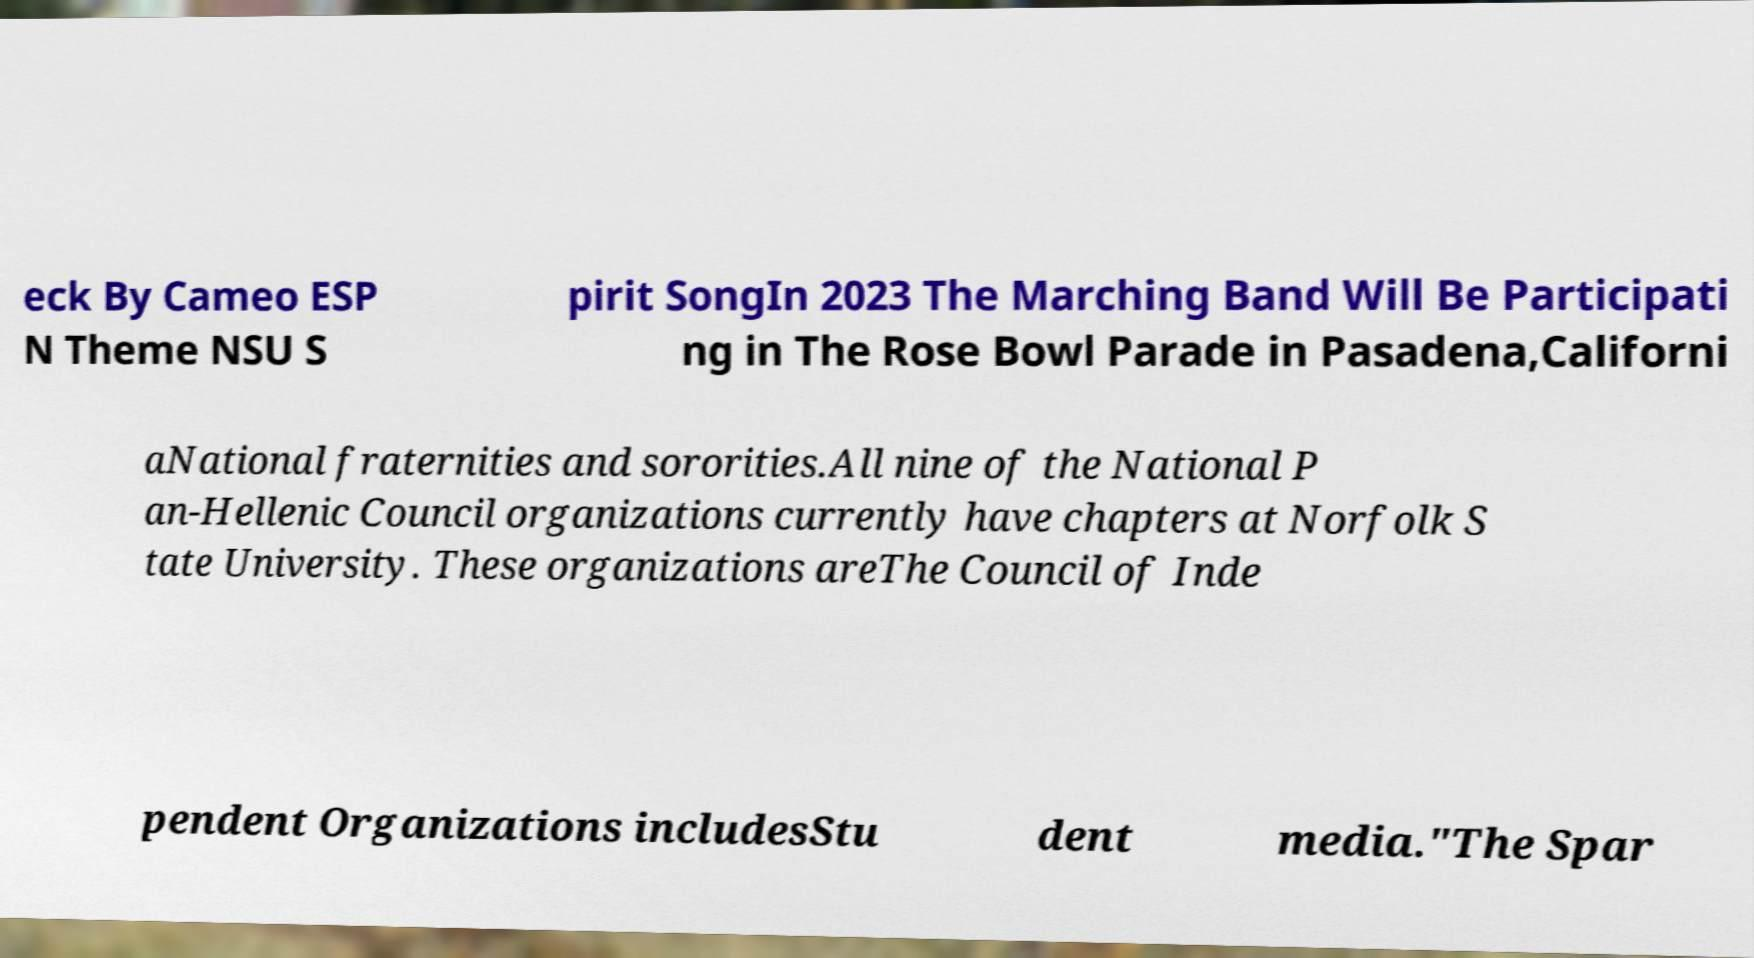For documentation purposes, I need the text within this image transcribed. Could you provide that? eck By Cameo ESP N Theme NSU S pirit SongIn 2023 The Marching Band Will Be Participati ng in The Rose Bowl Parade in Pasadena,Californi aNational fraternities and sororities.All nine of the National P an-Hellenic Council organizations currently have chapters at Norfolk S tate University. These organizations areThe Council of Inde pendent Organizations includesStu dent media."The Spar 